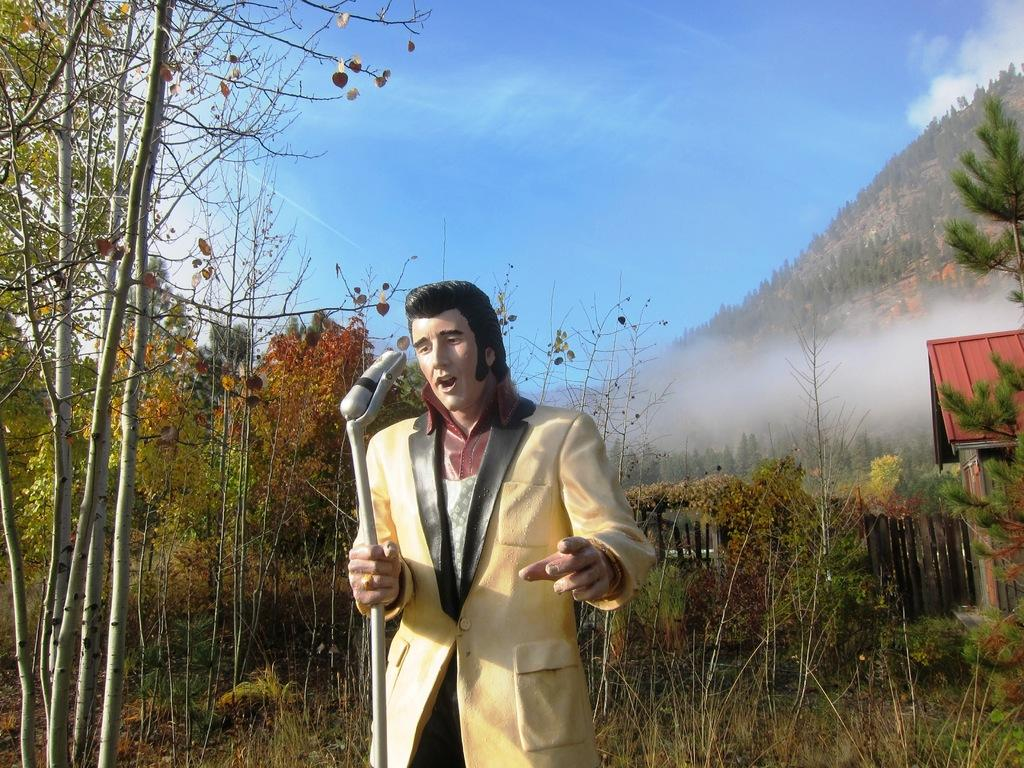What is the main subject of the sculpture in the image? The sculpture is of a person singing. What object is the person holding in the sculpture? The person is holding a microphone in the sculpture. What type of natural scenery can be seen in the background of the image? There are trees, mountains, and a shed visible in the background of the image. How many cows are grazing in the background of the image? There are no cows visible in the background of the image. What type of fruit is being harvested from the quince tree in the image? There is no quince tree present in the image. 